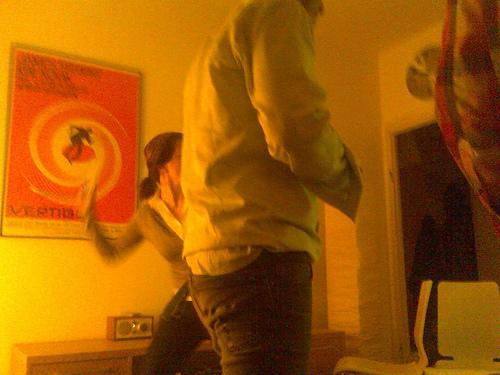What is the women about to do? play game 